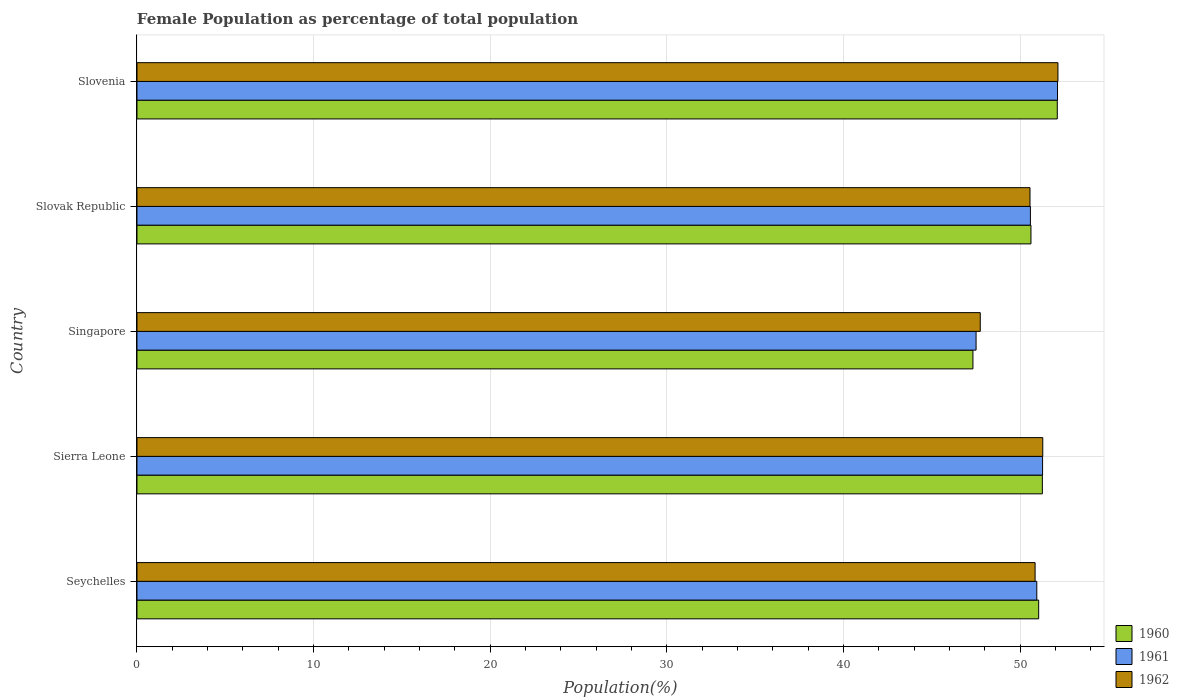How many groups of bars are there?
Provide a short and direct response. 5. How many bars are there on the 1st tick from the top?
Your response must be concise. 3. What is the label of the 3rd group of bars from the top?
Provide a succinct answer. Singapore. What is the female population in in 1960 in Seychelles?
Keep it short and to the point. 51.04. Across all countries, what is the maximum female population in in 1962?
Your answer should be very brief. 52.13. Across all countries, what is the minimum female population in in 1960?
Keep it short and to the point. 47.32. In which country was the female population in in 1962 maximum?
Ensure brevity in your answer.  Slovenia. In which country was the female population in in 1961 minimum?
Keep it short and to the point. Singapore. What is the total female population in in 1962 in the graph?
Provide a short and direct response. 252.53. What is the difference between the female population in in 1961 in Sierra Leone and that in Singapore?
Make the answer very short. 3.76. What is the difference between the female population in in 1962 in Sierra Leone and the female population in in 1960 in Singapore?
Your answer should be compact. 3.95. What is the average female population in in 1962 per country?
Provide a succinct answer. 50.51. What is the difference between the female population in in 1962 and female population in in 1961 in Slovak Republic?
Your answer should be compact. -0.02. What is the ratio of the female population in in 1960 in Sierra Leone to that in Singapore?
Provide a short and direct response. 1.08. What is the difference between the highest and the second highest female population in in 1960?
Make the answer very short. 0.85. What is the difference between the highest and the lowest female population in in 1962?
Give a very brief answer. 4.4. In how many countries, is the female population in in 1962 greater than the average female population in in 1962 taken over all countries?
Your answer should be very brief. 4. How many bars are there?
Offer a terse response. 15. How many countries are there in the graph?
Make the answer very short. 5. Are the values on the major ticks of X-axis written in scientific E-notation?
Provide a short and direct response. No. Does the graph contain any zero values?
Keep it short and to the point. No. Where does the legend appear in the graph?
Ensure brevity in your answer.  Bottom right. How are the legend labels stacked?
Make the answer very short. Vertical. What is the title of the graph?
Offer a terse response. Female Population as percentage of total population. What is the label or title of the X-axis?
Your answer should be compact. Population(%). What is the label or title of the Y-axis?
Give a very brief answer. Country. What is the Population(%) of 1960 in Seychelles?
Your answer should be compact. 51.04. What is the Population(%) of 1961 in Seychelles?
Provide a short and direct response. 50.94. What is the Population(%) of 1962 in Seychelles?
Give a very brief answer. 50.84. What is the Population(%) in 1960 in Sierra Leone?
Keep it short and to the point. 51.25. What is the Population(%) of 1961 in Sierra Leone?
Offer a very short reply. 51.26. What is the Population(%) in 1962 in Sierra Leone?
Your answer should be compact. 51.27. What is the Population(%) of 1960 in Singapore?
Provide a short and direct response. 47.32. What is the Population(%) of 1961 in Singapore?
Your response must be concise. 47.5. What is the Population(%) of 1962 in Singapore?
Provide a short and direct response. 47.74. What is the Population(%) in 1960 in Slovak Republic?
Ensure brevity in your answer.  50.61. What is the Population(%) of 1961 in Slovak Republic?
Keep it short and to the point. 50.57. What is the Population(%) in 1962 in Slovak Republic?
Ensure brevity in your answer.  50.55. What is the Population(%) in 1960 in Slovenia?
Your response must be concise. 52.1. What is the Population(%) in 1961 in Slovenia?
Provide a short and direct response. 52.11. What is the Population(%) of 1962 in Slovenia?
Keep it short and to the point. 52.13. Across all countries, what is the maximum Population(%) in 1960?
Your answer should be compact. 52.1. Across all countries, what is the maximum Population(%) of 1961?
Offer a very short reply. 52.11. Across all countries, what is the maximum Population(%) in 1962?
Ensure brevity in your answer.  52.13. Across all countries, what is the minimum Population(%) of 1960?
Your response must be concise. 47.32. Across all countries, what is the minimum Population(%) in 1961?
Your answer should be compact. 47.5. Across all countries, what is the minimum Population(%) of 1962?
Offer a terse response. 47.74. What is the total Population(%) of 1960 in the graph?
Make the answer very short. 252.31. What is the total Population(%) of 1961 in the graph?
Ensure brevity in your answer.  252.38. What is the total Population(%) in 1962 in the graph?
Your answer should be compact. 252.53. What is the difference between the Population(%) in 1960 in Seychelles and that in Sierra Leone?
Make the answer very short. -0.21. What is the difference between the Population(%) in 1961 in Seychelles and that in Sierra Leone?
Offer a very short reply. -0.33. What is the difference between the Population(%) in 1962 in Seychelles and that in Sierra Leone?
Offer a terse response. -0.43. What is the difference between the Population(%) in 1960 in Seychelles and that in Singapore?
Make the answer very short. 3.72. What is the difference between the Population(%) of 1961 in Seychelles and that in Singapore?
Provide a short and direct response. 3.44. What is the difference between the Population(%) in 1962 in Seychelles and that in Singapore?
Your response must be concise. 3.1. What is the difference between the Population(%) of 1960 in Seychelles and that in Slovak Republic?
Offer a very short reply. 0.44. What is the difference between the Population(%) in 1961 in Seychelles and that in Slovak Republic?
Ensure brevity in your answer.  0.36. What is the difference between the Population(%) in 1962 in Seychelles and that in Slovak Republic?
Offer a terse response. 0.29. What is the difference between the Population(%) in 1960 in Seychelles and that in Slovenia?
Offer a terse response. -1.05. What is the difference between the Population(%) of 1961 in Seychelles and that in Slovenia?
Keep it short and to the point. -1.17. What is the difference between the Population(%) of 1962 in Seychelles and that in Slovenia?
Your answer should be compact. -1.29. What is the difference between the Population(%) in 1960 in Sierra Leone and that in Singapore?
Ensure brevity in your answer.  3.93. What is the difference between the Population(%) in 1961 in Sierra Leone and that in Singapore?
Give a very brief answer. 3.76. What is the difference between the Population(%) of 1962 in Sierra Leone and that in Singapore?
Make the answer very short. 3.54. What is the difference between the Population(%) of 1960 in Sierra Leone and that in Slovak Republic?
Offer a very short reply. 0.65. What is the difference between the Population(%) of 1961 in Sierra Leone and that in Slovak Republic?
Provide a succinct answer. 0.69. What is the difference between the Population(%) in 1962 in Sierra Leone and that in Slovak Republic?
Provide a short and direct response. 0.72. What is the difference between the Population(%) in 1960 in Sierra Leone and that in Slovenia?
Keep it short and to the point. -0.84. What is the difference between the Population(%) in 1961 in Sierra Leone and that in Slovenia?
Your response must be concise. -0.84. What is the difference between the Population(%) of 1962 in Sierra Leone and that in Slovenia?
Give a very brief answer. -0.86. What is the difference between the Population(%) of 1960 in Singapore and that in Slovak Republic?
Offer a terse response. -3.28. What is the difference between the Population(%) of 1961 in Singapore and that in Slovak Republic?
Keep it short and to the point. -3.07. What is the difference between the Population(%) in 1962 in Singapore and that in Slovak Republic?
Make the answer very short. -2.82. What is the difference between the Population(%) of 1960 in Singapore and that in Slovenia?
Offer a terse response. -4.77. What is the difference between the Population(%) in 1961 in Singapore and that in Slovenia?
Your answer should be very brief. -4.61. What is the difference between the Population(%) in 1962 in Singapore and that in Slovenia?
Give a very brief answer. -4.4. What is the difference between the Population(%) in 1960 in Slovak Republic and that in Slovenia?
Provide a short and direct response. -1.49. What is the difference between the Population(%) in 1961 in Slovak Republic and that in Slovenia?
Offer a very short reply. -1.53. What is the difference between the Population(%) of 1962 in Slovak Republic and that in Slovenia?
Your response must be concise. -1.58. What is the difference between the Population(%) of 1960 in Seychelles and the Population(%) of 1961 in Sierra Leone?
Your answer should be compact. -0.22. What is the difference between the Population(%) of 1960 in Seychelles and the Population(%) of 1962 in Sierra Leone?
Make the answer very short. -0.23. What is the difference between the Population(%) in 1961 in Seychelles and the Population(%) in 1962 in Sierra Leone?
Offer a very short reply. -0.34. What is the difference between the Population(%) in 1960 in Seychelles and the Population(%) in 1961 in Singapore?
Offer a very short reply. 3.54. What is the difference between the Population(%) in 1960 in Seychelles and the Population(%) in 1962 in Singapore?
Your response must be concise. 3.31. What is the difference between the Population(%) of 1961 in Seychelles and the Population(%) of 1962 in Singapore?
Offer a terse response. 3.2. What is the difference between the Population(%) of 1960 in Seychelles and the Population(%) of 1961 in Slovak Republic?
Provide a short and direct response. 0.47. What is the difference between the Population(%) in 1960 in Seychelles and the Population(%) in 1962 in Slovak Republic?
Offer a terse response. 0.49. What is the difference between the Population(%) of 1961 in Seychelles and the Population(%) of 1962 in Slovak Republic?
Offer a very short reply. 0.39. What is the difference between the Population(%) in 1960 in Seychelles and the Population(%) in 1961 in Slovenia?
Your response must be concise. -1.07. What is the difference between the Population(%) in 1960 in Seychelles and the Population(%) in 1962 in Slovenia?
Give a very brief answer. -1.09. What is the difference between the Population(%) of 1961 in Seychelles and the Population(%) of 1962 in Slovenia?
Ensure brevity in your answer.  -1.2. What is the difference between the Population(%) in 1960 in Sierra Leone and the Population(%) in 1961 in Singapore?
Make the answer very short. 3.75. What is the difference between the Population(%) in 1960 in Sierra Leone and the Population(%) in 1962 in Singapore?
Keep it short and to the point. 3.52. What is the difference between the Population(%) in 1961 in Sierra Leone and the Population(%) in 1962 in Singapore?
Provide a succinct answer. 3.53. What is the difference between the Population(%) of 1960 in Sierra Leone and the Population(%) of 1961 in Slovak Republic?
Your answer should be compact. 0.68. What is the difference between the Population(%) of 1960 in Sierra Leone and the Population(%) of 1962 in Slovak Republic?
Your response must be concise. 0.7. What is the difference between the Population(%) in 1961 in Sierra Leone and the Population(%) in 1962 in Slovak Republic?
Make the answer very short. 0.71. What is the difference between the Population(%) of 1960 in Sierra Leone and the Population(%) of 1961 in Slovenia?
Give a very brief answer. -0.86. What is the difference between the Population(%) of 1960 in Sierra Leone and the Population(%) of 1962 in Slovenia?
Your answer should be compact. -0.88. What is the difference between the Population(%) of 1961 in Sierra Leone and the Population(%) of 1962 in Slovenia?
Provide a short and direct response. -0.87. What is the difference between the Population(%) of 1960 in Singapore and the Population(%) of 1961 in Slovak Republic?
Provide a short and direct response. -3.25. What is the difference between the Population(%) of 1960 in Singapore and the Population(%) of 1962 in Slovak Republic?
Make the answer very short. -3.23. What is the difference between the Population(%) of 1961 in Singapore and the Population(%) of 1962 in Slovak Republic?
Make the answer very short. -3.05. What is the difference between the Population(%) of 1960 in Singapore and the Population(%) of 1961 in Slovenia?
Offer a terse response. -4.79. What is the difference between the Population(%) in 1960 in Singapore and the Population(%) in 1962 in Slovenia?
Offer a very short reply. -4.81. What is the difference between the Population(%) of 1961 in Singapore and the Population(%) of 1962 in Slovenia?
Offer a very short reply. -4.63. What is the difference between the Population(%) of 1960 in Slovak Republic and the Population(%) of 1961 in Slovenia?
Offer a very short reply. -1.5. What is the difference between the Population(%) in 1960 in Slovak Republic and the Population(%) in 1962 in Slovenia?
Your answer should be very brief. -1.53. What is the difference between the Population(%) in 1961 in Slovak Republic and the Population(%) in 1962 in Slovenia?
Your response must be concise. -1.56. What is the average Population(%) in 1960 per country?
Provide a succinct answer. 50.46. What is the average Population(%) of 1961 per country?
Your answer should be very brief. 50.48. What is the average Population(%) of 1962 per country?
Ensure brevity in your answer.  50.51. What is the difference between the Population(%) of 1960 and Population(%) of 1961 in Seychelles?
Offer a very short reply. 0.11. What is the difference between the Population(%) of 1960 and Population(%) of 1962 in Seychelles?
Your response must be concise. 0.2. What is the difference between the Population(%) in 1961 and Population(%) in 1962 in Seychelles?
Your response must be concise. 0.1. What is the difference between the Population(%) in 1960 and Population(%) in 1961 in Sierra Leone?
Give a very brief answer. -0.01. What is the difference between the Population(%) of 1960 and Population(%) of 1962 in Sierra Leone?
Keep it short and to the point. -0.02. What is the difference between the Population(%) of 1961 and Population(%) of 1962 in Sierra Leone?
Keep it short and to the point. -0.01. What is the difference between the Population(%) of 1960 and Population(%) of 1961 in Singapore?
Provide a short and direct response. -0.18. What is the difference between the Population(%) in 1960 and Population(%) in 1962 in Singapore?
Your answer should be compact. -0.41. What is the difference between the Population(%) in 1961 and Population(%) in 1962 in Singapore?
Provide a short and direct response. -0.24. What is the difference between the Population(%) of 1960 and Population(%) of 1961 in Slovak Republic?
Give a very brief answer. 0.03. What is the difference between the Population(%) in 1960 and Population(%) in 1962 in Slovak Republic?
Give a very brief answer. 0.05. What is the difference between the Population(%) in 1961 and Population(%) in 1962 in Slovak Republic?
Your answer should be very brief. 0.02. What is the difference between the Population(%) in 1960 and Population(%) in 1961 in Slovenia?
Provide a succinct answer. -0.01. What is the difference between the Population(%) in 1960 and Population(%) in 1962 in Slovenia?
Provide a short and direct response. -0.04. What is the difference between the Population(%) in 1961 and Population(%) in 1962 in Slovenia?
Keep it short and to the point. -0.02. What is the ratio of the Population(%) of 1960 in Seychelles to that in Sierra Leone?
Offer a terse response. 1. What is the ratio of the Population(%) in 1961 in Seychelles to that in Sierra Leone?
Your answer should be very brief. 0.99. What is the ratio of the Population(%) of 1960 in Seychelles to that in Singapore?
Offer a very short reply. 1.08. What is the ratio of the Population(%) of 1961 in Seychelles to that in Singapore?
Your answer should be very brief. 1.07. What is the ratio of the Population(%) in 1962 in Seychelles to that in Singapore?
Provide a short and direct response. 1.06. What is the ratio of the Population(%) of 1960 in Seychelles to that in Slovak Republic?
Your response must be concise. 1.01. What is the ratio of the Population(%) of 1962 in Seychelles to that in Slovak Republic?
Provide a short and direct response. 1.01. What is the ratio of the Population(%) of 1960 in Seychelles to that in Slovenia?
Provide a succinct answer. 0.98. What is the ratio of the Population(%) in 1961 in Seychelles to that in Slovenia?
Ensure brevity in your answer.  0.98. What is the ratio of the Population(%) of 1962 in Seychelles to that in Slovenia?
Provide a succinct answer. 0.98. What is the ratio of the Population(%) in 1960 in Sierra Leone to that in Singapore?
Your answer should be very brief. 1.08. What is the ratio of the Population(%) of 1961 in Sierra Leone to that in Singapore?
Your answer should be compact. 1.08. What is the ratio of the Population(%) of 1962 in Sierra Leone to that in Singapore?
Give a very brief answer. 1.07. What is the ratio of the Population(%) in 1960 in Sierra Leone to that in Slovak Republic?
Provide a succinct answer. 1.01. What is the ratio of the Population(%) in 1961 in Sierra Leone to that in Slovak Republic?
Your answer should be very brief. 1.01. What is the ratio of the Population(%) in 1962 in Sierra Leone to that in Slovak Republic?
Offer a terse response. 1.01. What is the ratio of the Population(%) in 1960 in Sierra Leone to that in Slovenia?
Your response must be concise. 0.98. What is the ratio of the Population(%) in 1961 in Sierra Leone to that in Slovenia?
Ensure brevity in your answer.  0.98. What is the ratio of the Population(%) in 1962 in Sierra Leone to that in Slovenia?
Your answer should be very brief. 0.98. What is the ratio of the Population(%) in 1960 in Singapore to that in Slovak Republic?
Your answer should be compact. 0.94. What is the ratio of the Population(%) in 1961 in Singapore to that in Slovak Republic?
Offer a terse response. 0.94. What is the ratio of the Population(%) in 1962 in Singapore to that in Slovak Republic?
Your answer should be compact. 0.94. What is the ratio of the Population(%) of 1960 in Singapore to that in Slovenia?
Keep it short and to the point. 0.91. What is the ratio of the Population(%) of 1961 in Singapore to that in Slovenia?
Provide a succinct answer. 0.91. What is the ratio of the Population(%) of 1962 in Singapore to that in Slovenia?
Offer a terse response. 0.92. What is the ratio of the Population(%) in 1960 in Slovak Republic to that in Slovenia?
Provide a short and direct response. 0.97. What is the ratio of the Population(%) of 1961 in Slovak Republic to that in Slovenia?
Offer a terse response. 0.97. What is the ratio of the Population(%) of 1962 in Slovak Republic to that in Slovenia?
Your answer should be very brief. 0.97. What is the difference between the highest and the second highest Population(%) of 1960?
Your answer should be compact. 0.84. What is the difference between the highest and the second highest Population(%) of 1961?
Provide a succinct answer. 0.84. What is the difference between the highest and the second highest Population(%) of 1962?
Keep it short and to the point. 0.86. What is the difference between the highest and the lowest Population(%) of 1960?
Offer a very short reply. 4.77. What is the difference between the highest and the lowest Population(%) of 1961?
Provide a succinct answer. 4.61. What is the difference between the highest and the lowest Population(%) of 1962?
Make the answer very short. 4.4. 